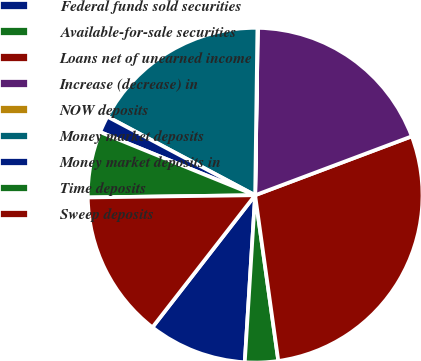Convert chart. <chart><loc_0><loc_0><loc_500><loc_500><pie_chart><fcel>Federal funds sold securities<fcel>Available-for-sale securities<fcel>Loans net of unearned income<fcel>Increase (decrease) in<fcel>NOW deposits<fcel>Money market deposits<fcel>Money market deposits in<fcel>Time deposits<fcel>Sweep deposits<nl><fcel>9.53%<fcel>3.2%<fcel>28.51%<fcel>19.02%<fcel>0.04%<fcel>17.44%<fcel>1.62%<fcel>6.37%<fcel>14.27%<nl></chart> 